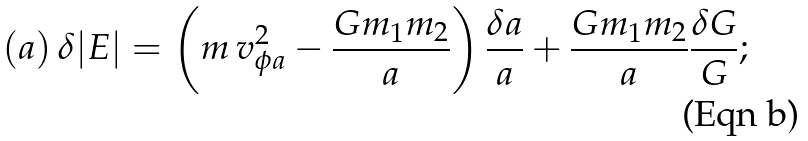Convert formula to latex. <formula><loc_0><loc_0><loc_500><loc_500>( a ) \, \delta | E | = \left ( m \, v _ { \phi a } ^ { 2 } - \frac { G m _ { 1 } m _ { 2 } } { a } \right ) \frac { \delta a } { a } + \frac { G m _ { 1 } m _ { 2 } } { a } \frac { \delta G } { G } ;</formula> 